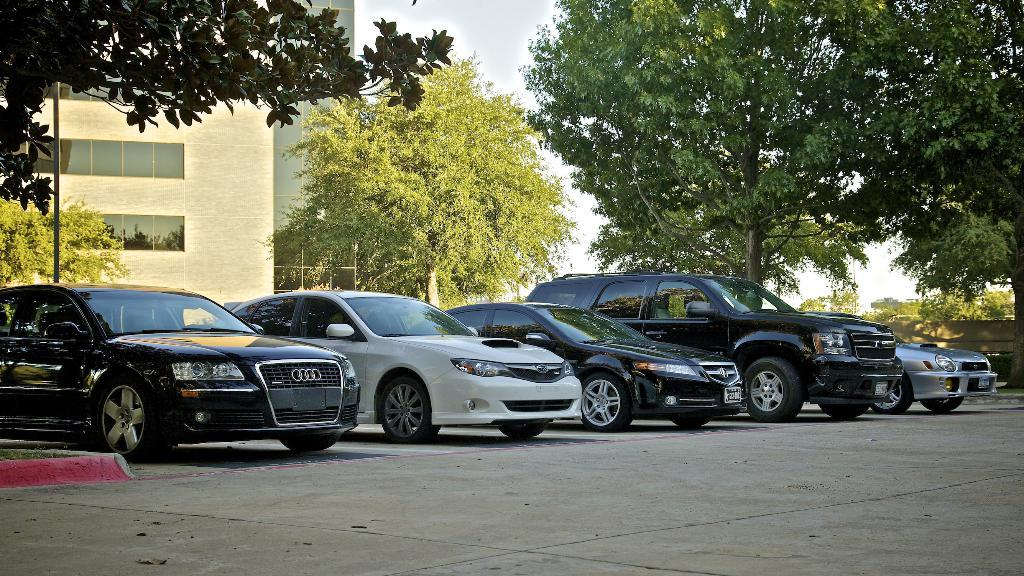What can be seen on the road in the image? There are vehicles on the road in the image. What is the tall, vertical object in the image? There is a pole in the image. What type of structure is visible in the image? There is a building in the image. What type of vegetation is present in the image? There are trees in the image. What is visible in the background of the image? The sky is visible in the background of the image. What type of health advice is being given by the ring in the image? There is no ring present in the image, and therefore no health advice can be given. How does the tail of the vehicle in the image help it move? There is no mention of a tail on the vehicles in the image, and they do not require tails to move. 